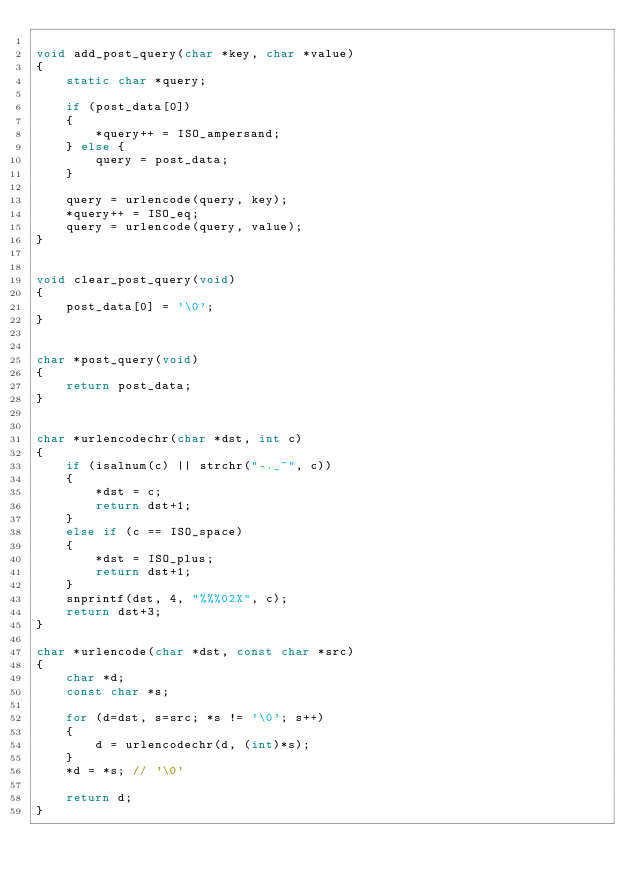<code> <loc_0><loc_0><loc_500><loc_500><_C_>
void add_post_query(char *key, char *value)
{
    static char *query;
    
    if (post_data[0])
    {
        *query++ = ISO_ampersand;
    } else {
        query = post_data;
    }
    
    query = urlencode(query, key);
    *query++ = ISO_eq;
    query = urlencode(query, value);
}


void clear_post_query(void)
{
    post_data[0] = '\0';
}


char *post_query(void)
{
    return post_data;
}


char *urlencodechr(char *dst, int c)
{
    if (isalnum(c) || strchr("-._~", c))
    {
        *dst = c;
        return dst+1;
    }
    else if (c == ISO_space)
    {
        *dst = ISO_plus;
        return dst+1;
    }
    snprintf(dst, 4, "%%%02X", c);
    return dst+3;
}

char *urlencode(char *dst, const char *src)
{
    char *d;
    const char *s;
    
    for (d=dst, s=src; *s != '\0'; s++)
    {
        d = urlencodechr(d, (int)*s);
    }
    *d = *s; // '\0'
    
    return d;
}
</code> 